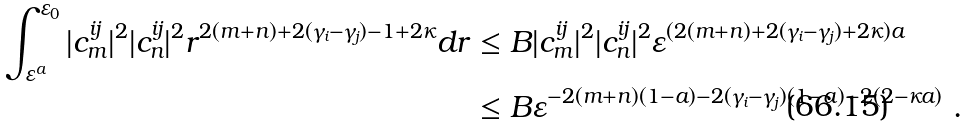Convert formula to latex. <formula><loc_0><loc_0><loc_500><loc_500>\int _ { \varepsilon ^ { a } } ^ { \varepsilon _ { 0 } } | c _ { m } ^ { i j } | ^ { 2 } | c _ { n } ^ { i j } | ^ { 2 } r ^ { 2 ( m + n ) + 2 ( \gamma _ { i } - \gamma _ { j } ) - 1 + 2 \kappa } d r & \leq B | c _ { m } ^ { i j } | ^ { 2 } | c _ { n } ^ { i j } | ^ { 2 } \varepsilon ^ { ( 2 ( m + n ) + 2 ( \gamma _ { i } - \gamma _ { j } ) + 2 \kappa ) a } \\ & \leq B \varepsilon ^ { - 2 ( m + n ) ( 1 - a ) - 2 ( \gamma _ { i } - \gamma _ { j } ) ( 1 - a ) - 2 ( 2 - \kappa a ) } \ .</formula> 